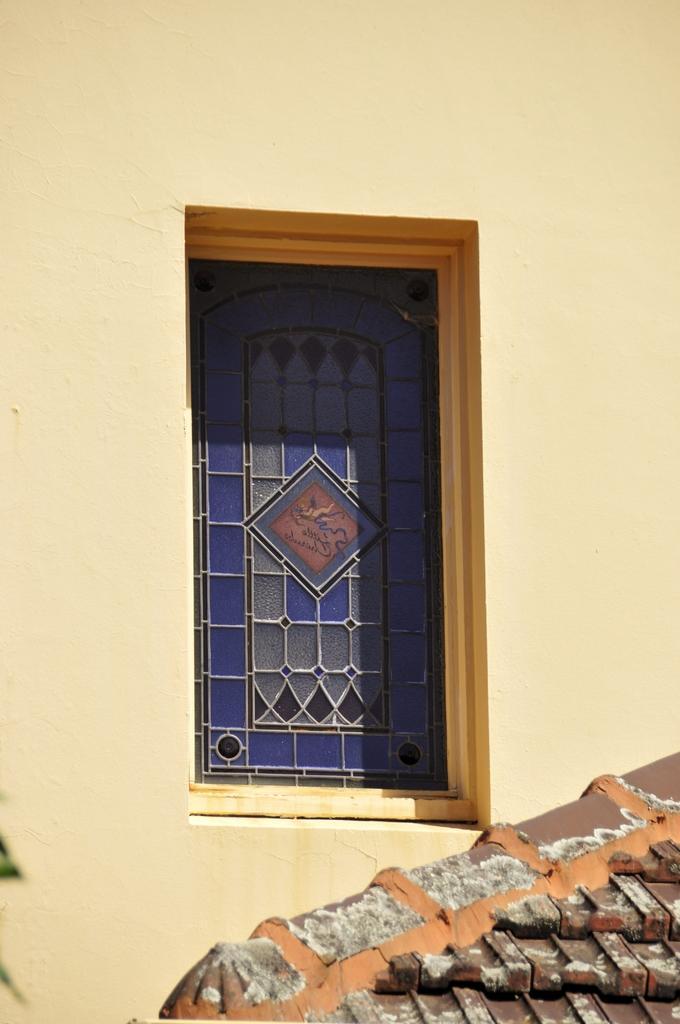Can you describe this image briefly? In this image we can see a wall, window and a roof of a house. 